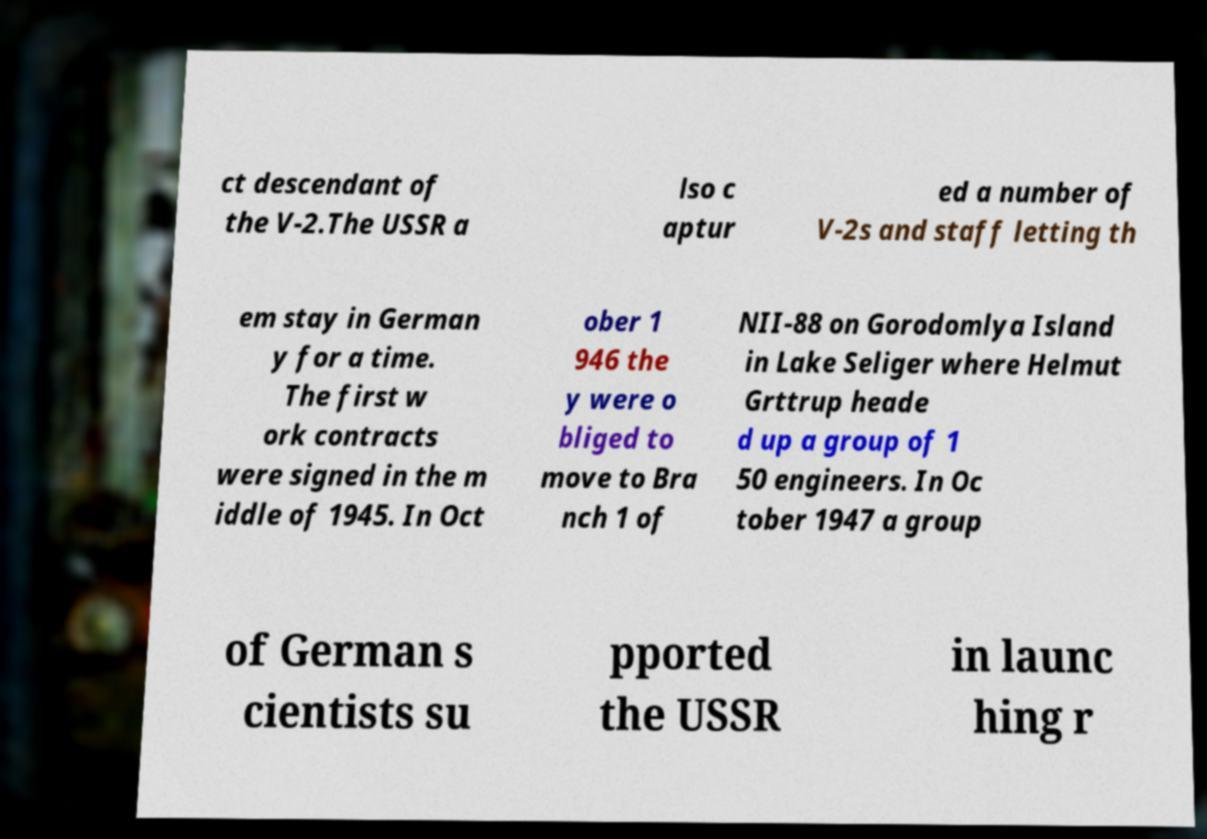For documentation purposes, I need the text within this image transcribed. Could you provide that? ct descendant of the V-2.The USSR a lso c aptur ed a number of V-2s and staff letting th em stay in German y for a time. The first w ork contracts were signed in the m iddle of 1945. In Oct ober 1 946 the y were o bliged to move to Bra nch 1 of NII-88 on Gorodomlya Island in Lake Seliger where Helmut Grttrup heade d up a group of 1 50 engineers. In Oc tober 1947 a group of German s cientists su pported the USSR in launc hing r 